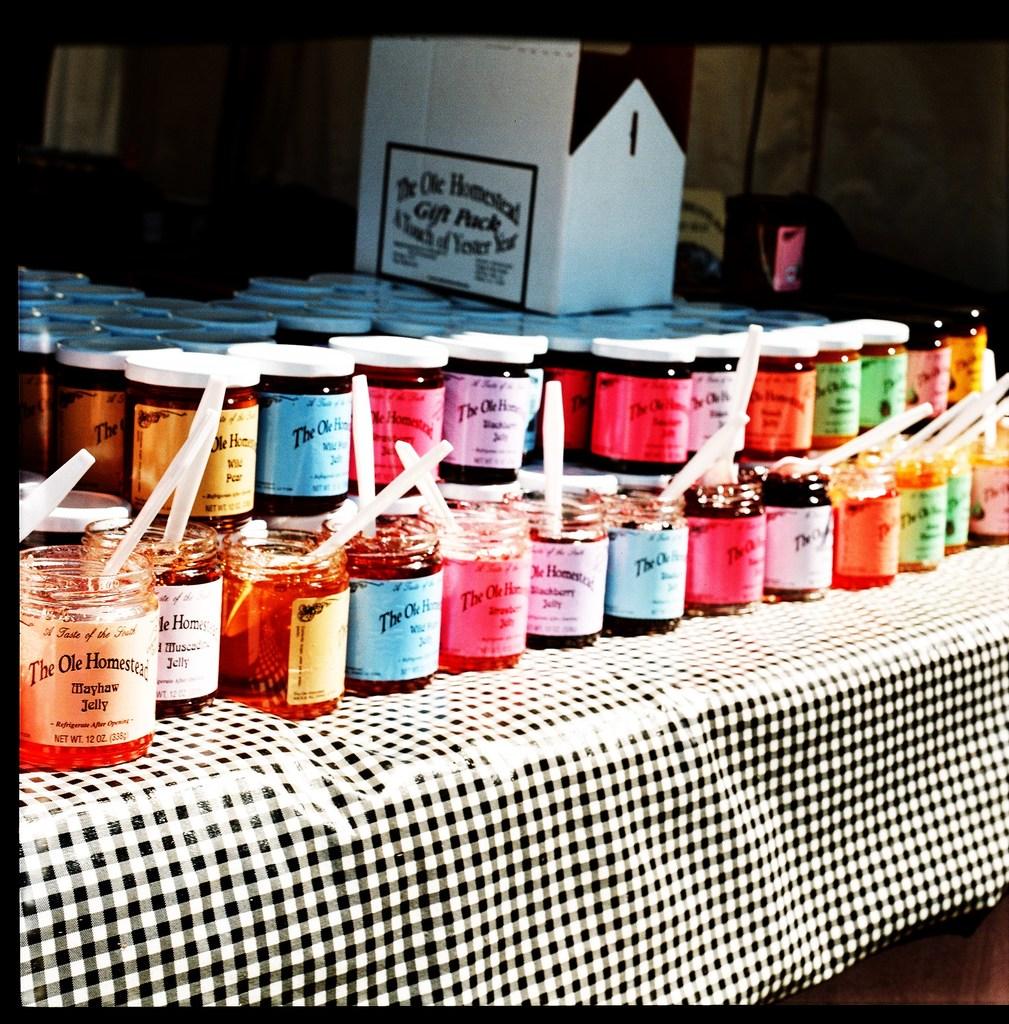What kind of pack is the cardboard box for?
Your response must be concise. Gift pack. What brand is labeled on the jar?
Provide a short and direct response. The ole homestead. 